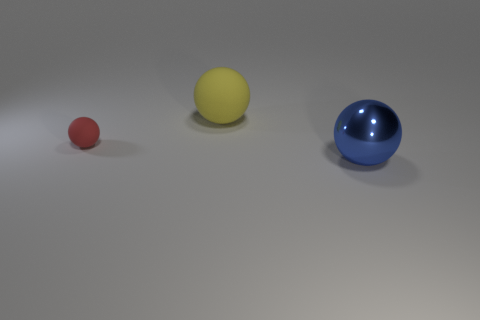Do the surface textures of the balls suggest what material they might be made from? Based on the reflections and shadings on the surfaces, the red and blue balls seem to have a glossy, perhaps plastic-like finish, while the yellow ball has a more matte appearance, which could suggest a rubber or non-reflective plastic material. These textures add another layer of interest to the image, showcasing how light interacts with objects of different colors and finishes. Given their different textures, how might these balls feel to the touch? If we could touch them, the red and blue glossy balls would likely feel smooth and maybe a bit slippery, while the matte yellow ball might have a more grippable surface, feeling slightly rougher in comparison. These tactile qualities could make each ball more or less suitable for certain activities or handling. 